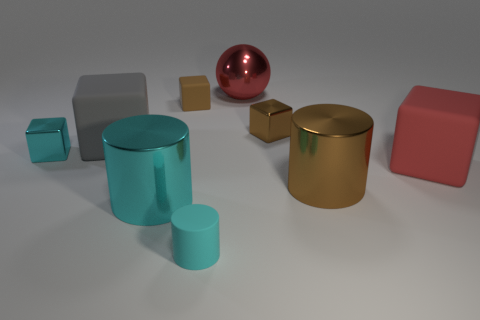What color is the large block in front of the big gray thing? The large block situated prominently in front of the sizable gray object has a rich, shiny red hue, reminiscent of a cherry or a ruby. 